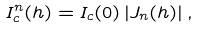<formula> <loc_0><loc_0><loc_500><loc_500>I _ { c } ^ { n } ( h ) = I _ { c } ( 0 ) \left | J _ { n } ( h ) \right | ,</formula> 